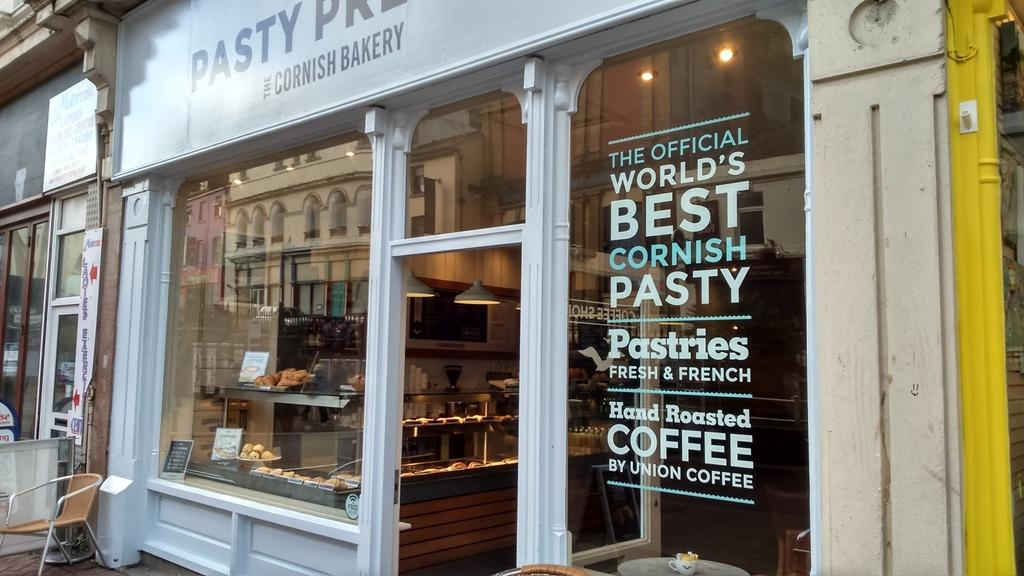<image>
Provide a brief description of the given image. The exterior of a bakers shop with a window full of goodies on display and a sign saying the shop sells the the official worlds greatest cornish pasty. 